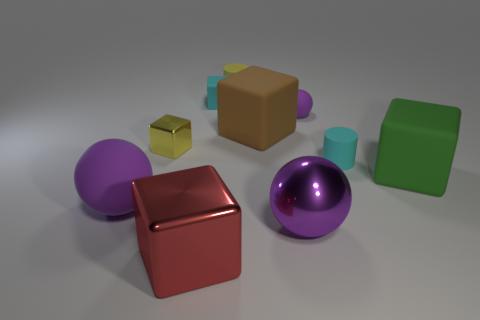Subtract all small metal blocks. How many blocks are left? 4 Subtract all yellow cylinders. How many cylinders are left? 1 Subtract all spheres. How many objects are left? 7 Subtract 2 cylinders. How many cylinders are left? 0 Add 5 tiny cyan objects. How many tiny cyan objects are left? 7 Add 6 small brown spheres. How many small brown spheres exist? 6 Subtract 1 brown blocks. How many objects are left? 9 Subtract all green blocks. Subtract all yellow balls. How many blocks are left? 4 Subtract all tiny metal things. Subtract all tiny cyan rubber things. How many objects are left? 7 